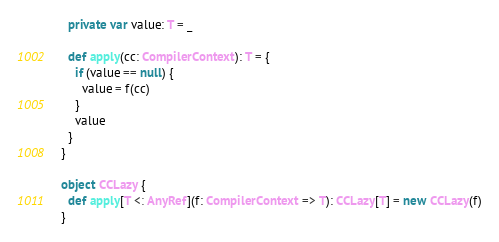Convert code to text. <code><loc_0><loc_0><loc_500><loc_500><_Scala_>  private var value: T = _

  def apply(cc: CompilerContext): T = {
    if (value == null) {
      value = f(cc)
    }
    value
  }
}

object CCLazy {
  def apply[T <: AnyRef](f: CompilerContext => T): CCLazy[T] = new CCLazy(f)
}
</code> 